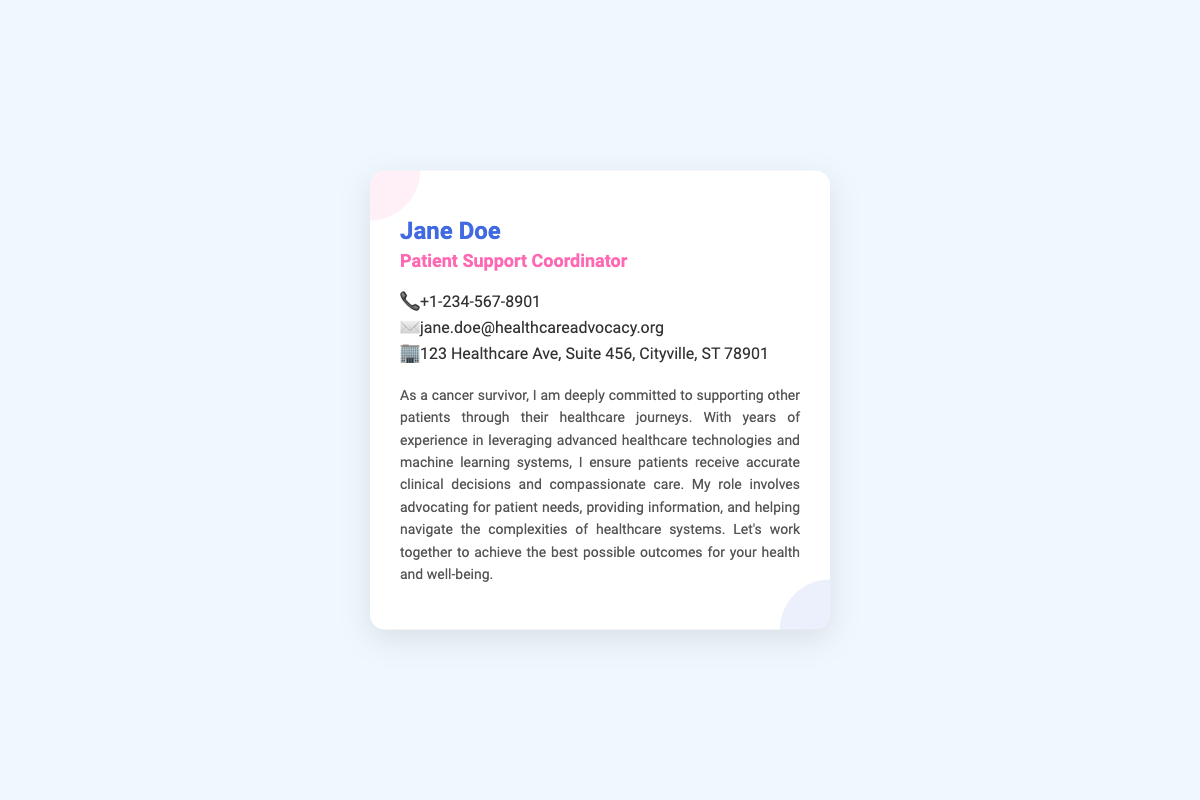what is the name of the Patient Support Coordinator? The document clearly states the name of the Patient Support Coordinator at the top as Jane Doe.
Answer: Jane Doe what is the contact phone number? The document provides a phone number under the contact info section, which is +1-234-567-8901.
Answer: +1-234-567-8901 what is the email address listed? The email address provided in the document for contacting is jane.doe@healthcareadvocacy.org.
Answer: jane.doe@healthcareadvocacy.org what city is the office located in? The document mentions the office's location, specifying Cityville as the city.
Answer: Cityville how many years of experience does Jane have? While the document does not specify an exact number of years, it states she has years of experience in her role.
Answer: years of experience (not specified) what is Jane's approach to supporting patients? The document describes her commitment to supporting other patients through their healthcare journeys.
Answer: supporting other patients what technology does Jane leverage? The document mentions that she utilizes advanced healthcare technologies and machine learning systems.
Answer: advanced healthcare technologies and machine learning systems what is the primary role of a Patient Support Coordinator as described? The document states that her role involves advocating for patient needs and helping navigate healthcare complexities.
Answer: advocating for patient needs what is the significance of Jane's personal experience? The document highlights that her experience as a cancer survivor drives her commitment to support other patients.
Answer: cancer survivor 